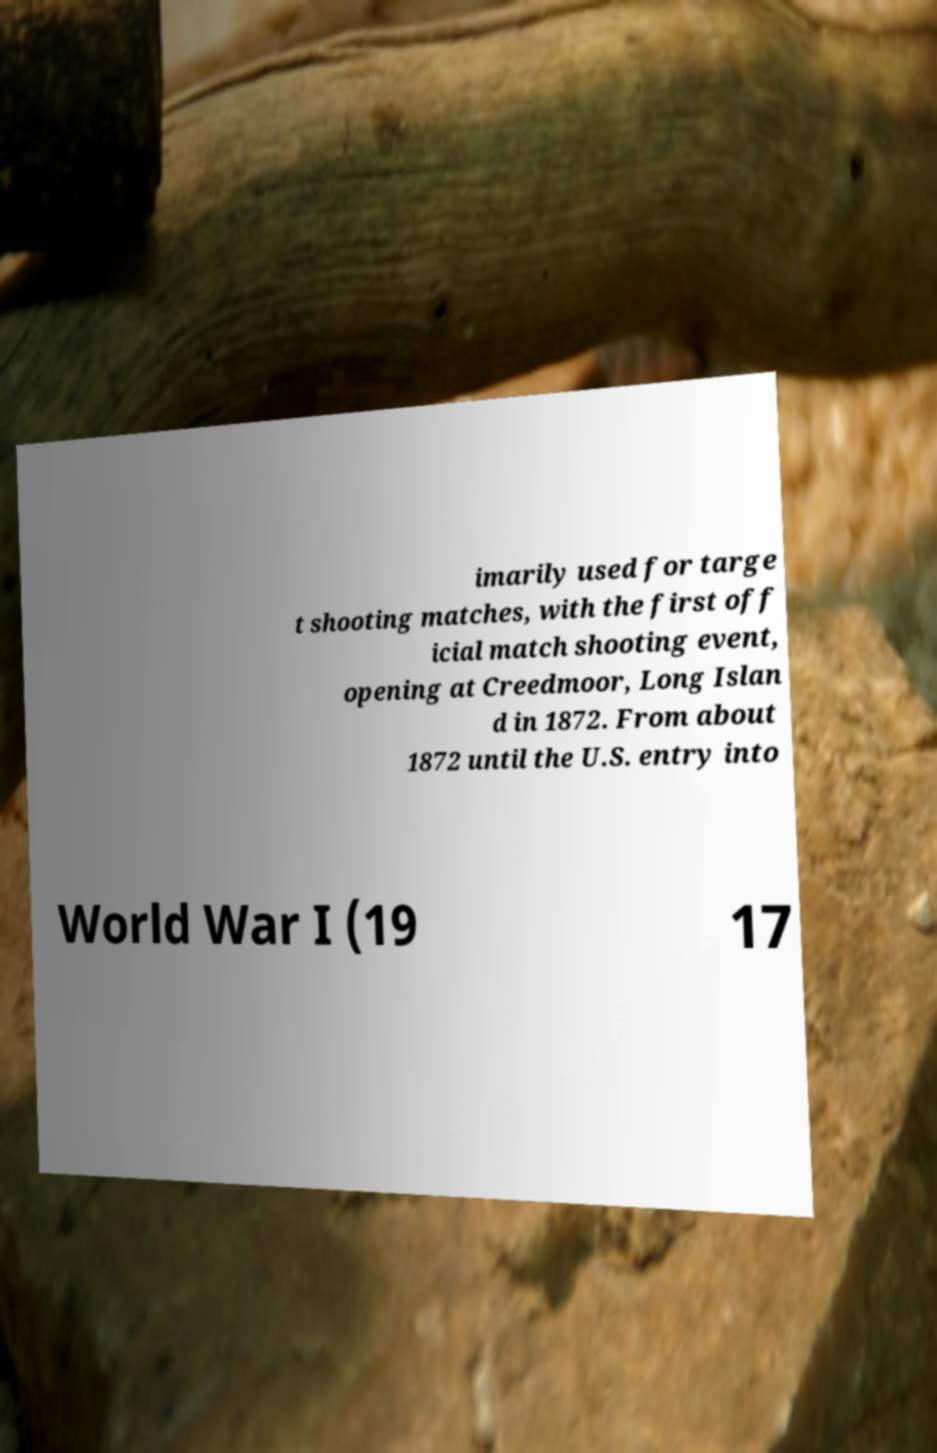Could you assist in decoding the text presented in this image and type it out clearly? imarily used for targe t shooting matches, with the first off icial match shooting event, opening at Creedmoor, Long Islan d in 1872. From about 1872 until the U.S. entry into World War I (19 17 